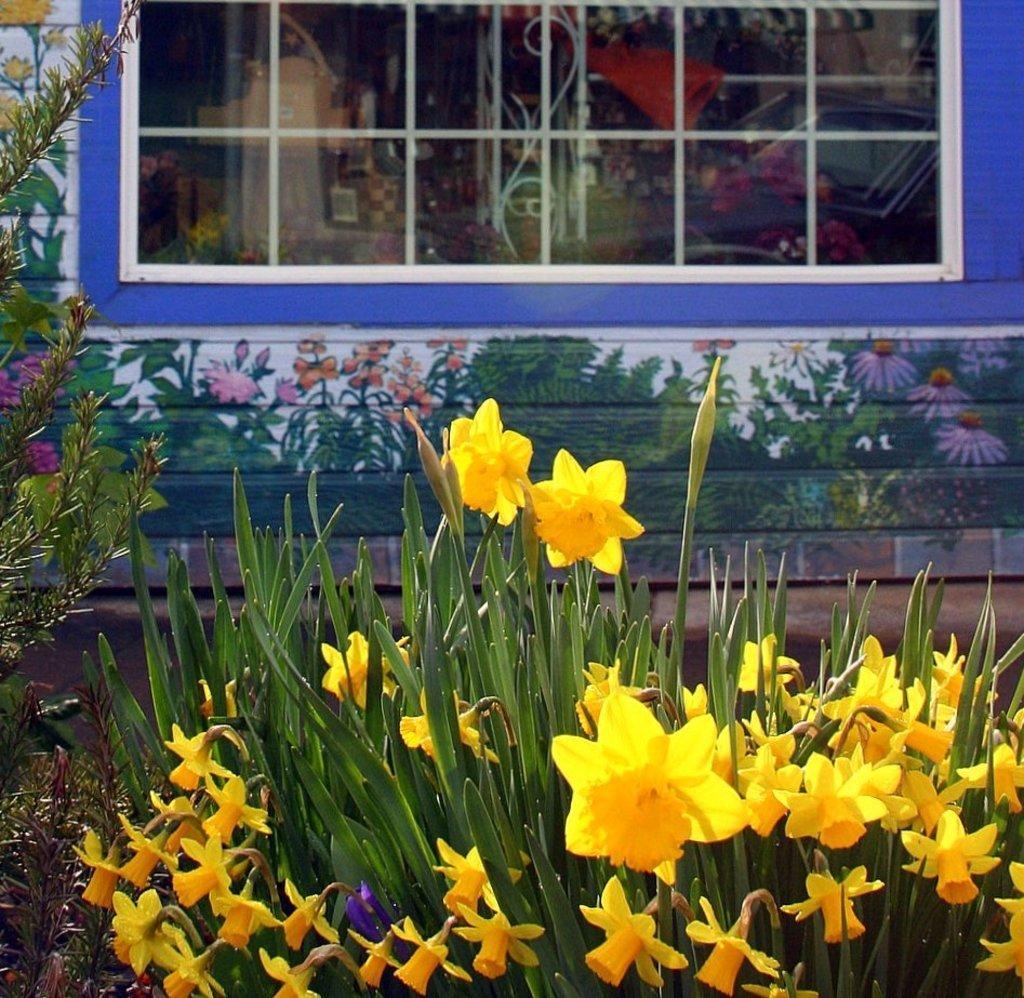In one or two sentences, can you explain what this image depicts? In the image we can see there are yellow colour flowers on the plants. Behind there is window on the wall of a building and there are paintings of plants and flowers on the wall. 